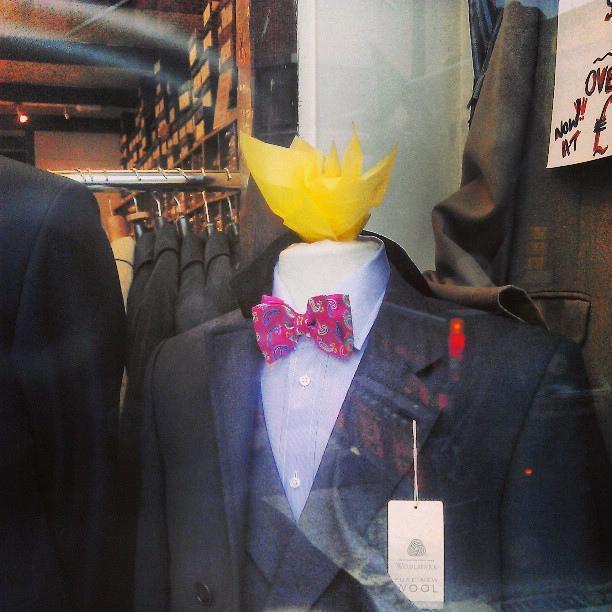How many zebra are located in the image?
Give a very brief answer. 0. 